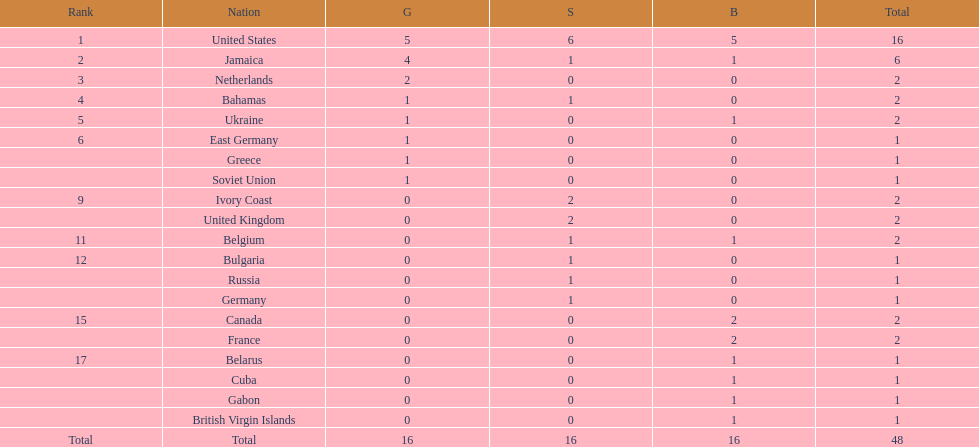How many nations won no gold medals? 12. 